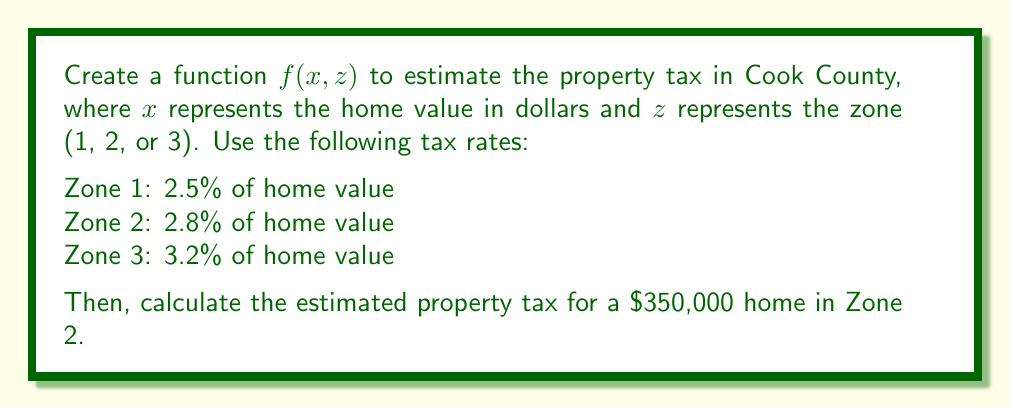What is the answer to this math problem? 1. Define the function $f(x, z)$ based on the given tax rates:

   $$f(x, z) = \begin{cases}
   0.025x & \text{if } z = 1 \\
   0.028x & \text{if } z = 2 \\
   0.032x & \text{if } z = 3
   \end{cases}$$

2. To calculate the estimated property tax for a $350,000 home in Zone 2:
   - Home value: $x = 350,000$
   - Zone: $z = 2$

3. Use the function for Zone 2: $f(x, 2) = 0.028x$

4. Substitute the home value:
   $f(350000, 2) = 0.028 \times 350000$

5. Calculate:
   $f(350000, 2) = 9800$

Therefore, the estimated property tax for a $350,000 home in Zone 2 is $9,800.
Answer: $9,800 